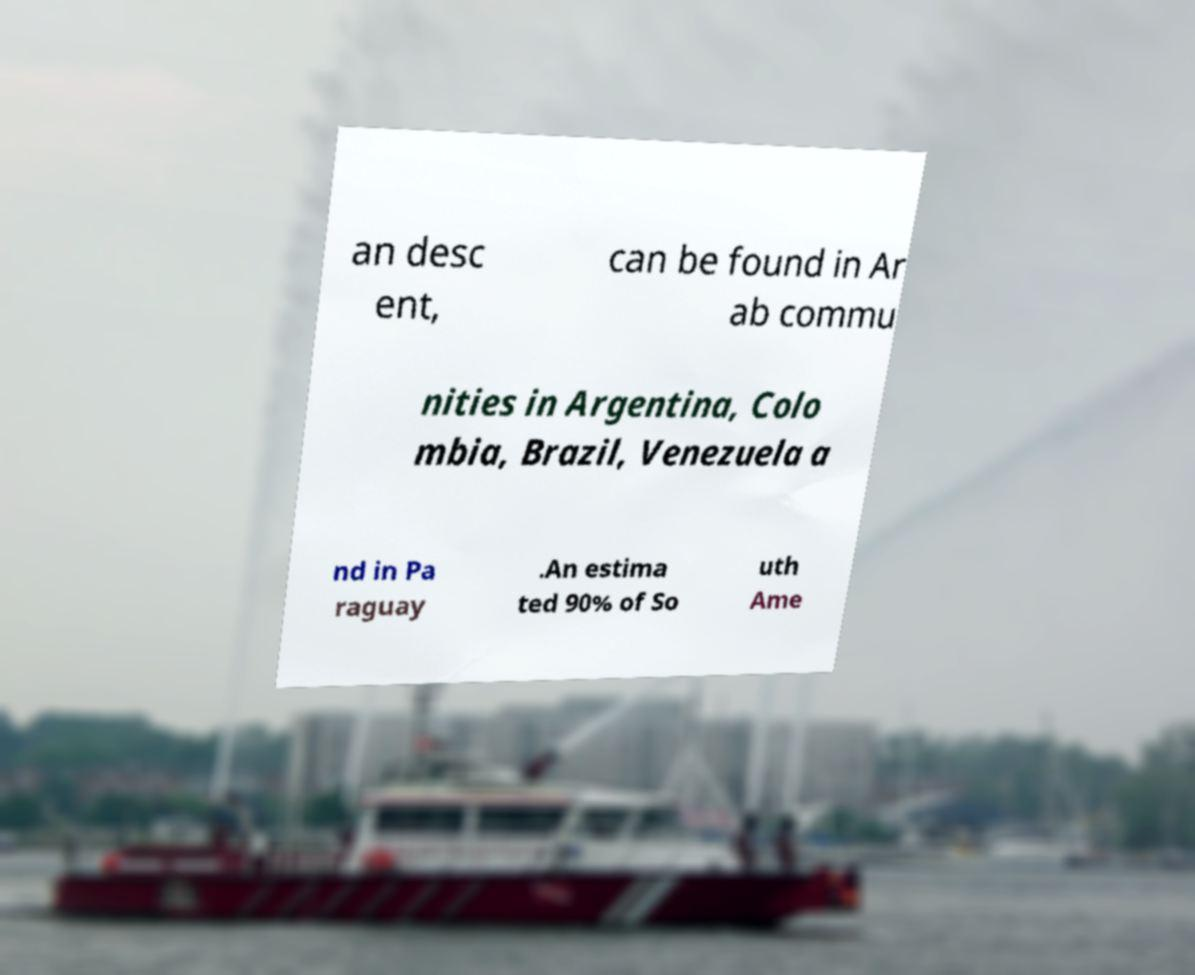Could you extract and type out the text from this image? an desc ent, can be found in Ar ab commu nities in Argentina, Colo mbia, Brazil, Venezuela a nd in Pa raguay .An estima ted 90% of So uth Ame 